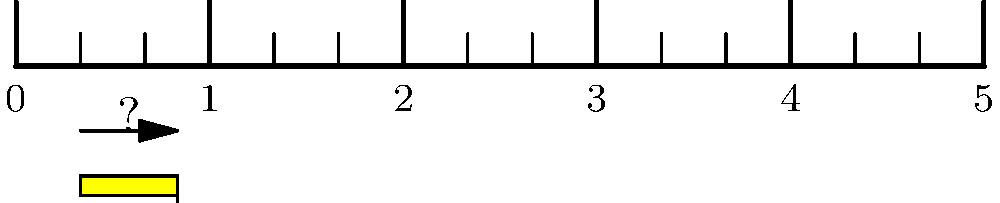Your child is struggling to measure the length of a pencil using a ruler. The pencil is shown above the ruler in the image. How many inches long is the pencil? Let's break this down step-by-step to help your child understand:

1. First, we need to identify the units on the ruler. Each number represents 1 inch, and there are smaller marks between them.

2. The ruler is divided into inches, with each inch further divided into 4 equal parts. Each small mark represents $\frac{1}{4}$ or 0.25 inches.

3. Looking at the pencil, we can see that it starts just after the 0 mark and ends between 1 and 2 inches.

4. To be precise, the pencil ends at the 5th small mark after the 1-inch mark.

5. We can count: 1 inch + 5 quarter-inches
   
   $1 + (\frac{1}{4} + \frac{1}{4} + \frac{1}{4} + \frac{1}{4} + \frac{1}{4})$
   
   $= 1 + \frac{5}{4}$
   
   $= 1 + 1\frac{1}{4}$
   
   $= 2\frac{1}{4}$ inches

6. In decimal form, this is equal to 2.25 inches.

Encourage your child to practice counting the small marks and understanding that four of them make up one inch. This will help them become more comfortable with fractions and measurements.
Answer: $2\frac{1}{4}$ inches or 2.25 inches 